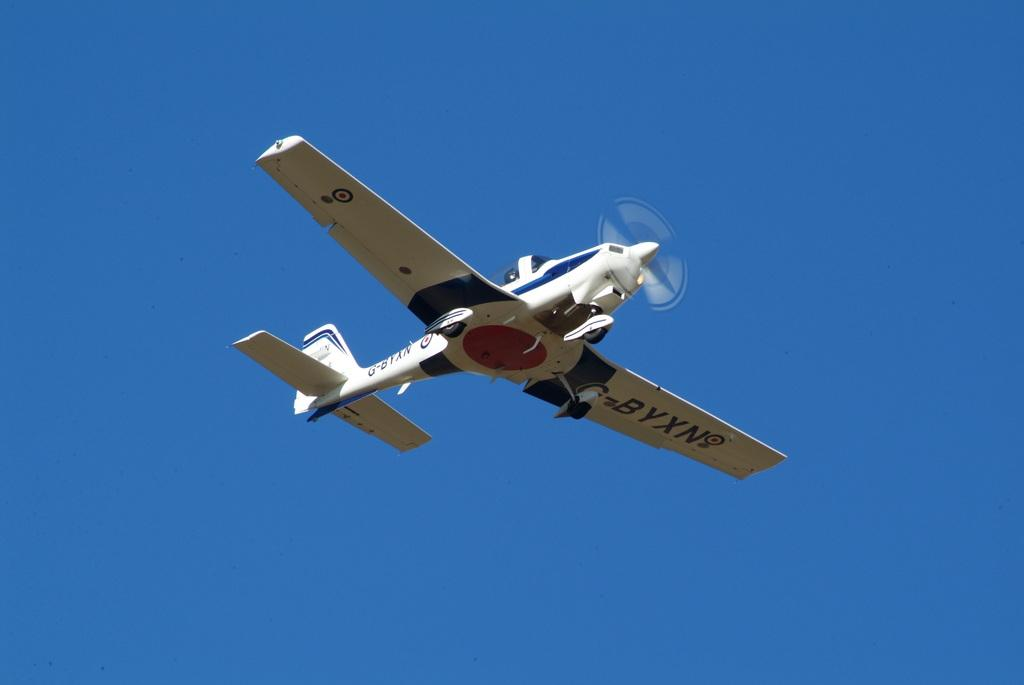What is the main subject of the image? The main subject of the image is an aircraft. What is the aircraft doing in the image? The aircraft is flying in the image. How would you describe the weather based on the image? The sky is sunny in the image. Where is the boundary between the park and the fire in the image? There is no park or fire present in the image; it only features an aircraft flying in a sunny sky. 